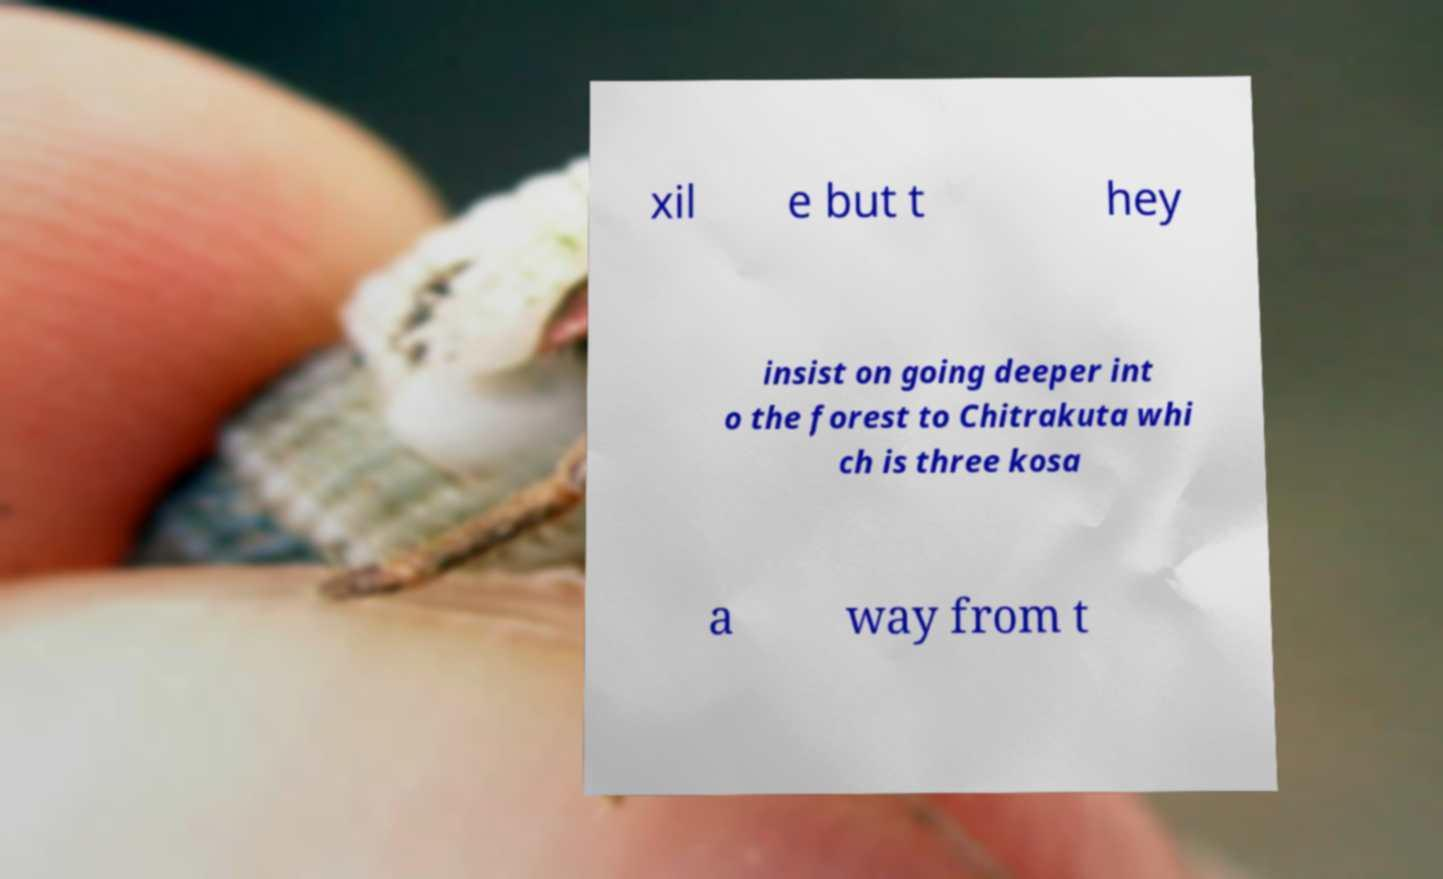Could you extract and type out the text from this image? xil e but t hey insist on going deeper int o the forest to Chitrakuta whi ch is three kosa a way from t 